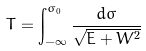<formula> <loc_0><loc_0><loc_500><loc_500>T = \int _ { - \infty } ^ { \sigma _ { 0 } } \frac { d \sigma } { \sqrt { E + W ^ { 2 } } }</formula> 